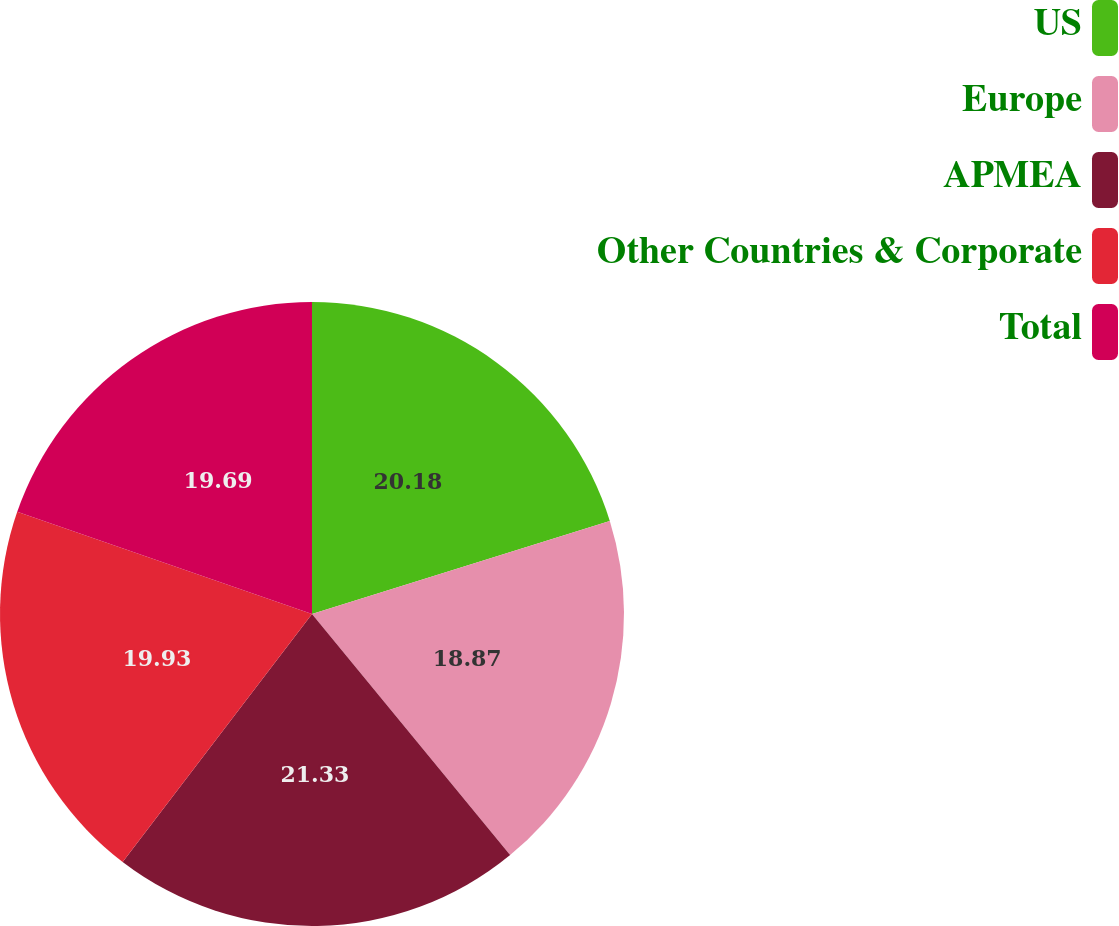<chart> <loc_0><loc_0><loc_500><loc_500><pie_chart><fcel>US<fcel>Europe<fcel>APMEA<fcel>Other Countries & Corporate<fcel>Total<nl><fcel>20.18%<fcel>18.87%<fcel>21.33%<fcel>19.93%<fcel>19.69%<nl></chart> 